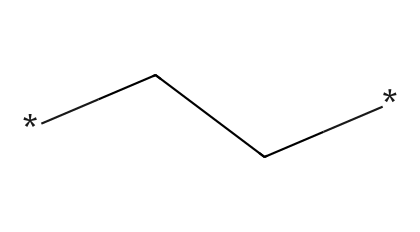What is the repeating unit in polyethylene? The SMILES representation shows a simple alkane chain which is the building block for polyethylene, specifically the ethylene monomer (CH2-CH2) repeating to form the polymer.
Answer: CH2-CH2 How many carbon atoms are in the structure? Analyzing the SMILES, there is one carbon atom in each repeating unit, and since there's typically a long chain, we can deduce multiple carbons are present. The specific representation shows 2 carbon atoms in the simplest form.
Answer: 2 What type of bonding is present in polyethylene? The SMILES representation indicates the presence of single bonds (sigma bonds) between carbon atoms, which are characteristic of saturated hydrocarbons like polyethylene.
Answer: single bonds What is the main characteristic of the chemical structure of polyethylene? The structure consists mainly of long, unbranched chains of carbon with hydrogen, making it a typical characteristic of polymers. This results in a linear form that is key to its properties like flexibility and toughness.
Answer: unbranched chains What physical property is influenced by the polymer structure of polyethylene? The long chain structure of polyethylene contributes to its low density and flexibility, influencing its mechanical behavior and making it suitable for various applications including handball equipment.
Answer: low density How does the polymerization process affect polyethylene's properties? The polymerization process transforms small ethylene monomers (as seen in the SMILES) into long macromolecules, altering its physical properties such as elasticity, tensile strength, and thermal resistance, essential for impact resistance in sports equipment.
Answer: alters properties 